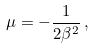<formula> <loc_0><loc_0><loc_500><loc_500>\mu = - \frac { 1 } { 2 \beta ^ { 2 } } \, ,</formula> 